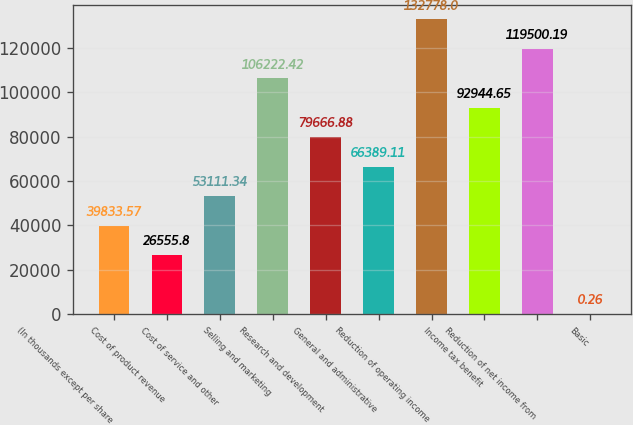Convert chart to OTSL. <chart><loc_0><loc_0><loc_500><loc_500><bar_chart><fcel>(In thousands except per share<fcel>Cost of product revenue<fcel>Cost of service and other<fcel>Selling and marketing<fcel>Research and development<fcel>General and administrative<fcel>Reduction of operating income<fcel>Income tax benefit<fcel>Reduction of net income from<fcel>Basic<nl><fcel>39833.6<fcel>26555.8<fcel>53111.3<fcel>106222<fcel>79666.9<fcel>66389.1<fcel>132778<fcel>92944.6<fcel>119500<fcel>0.26<nl></chart> 